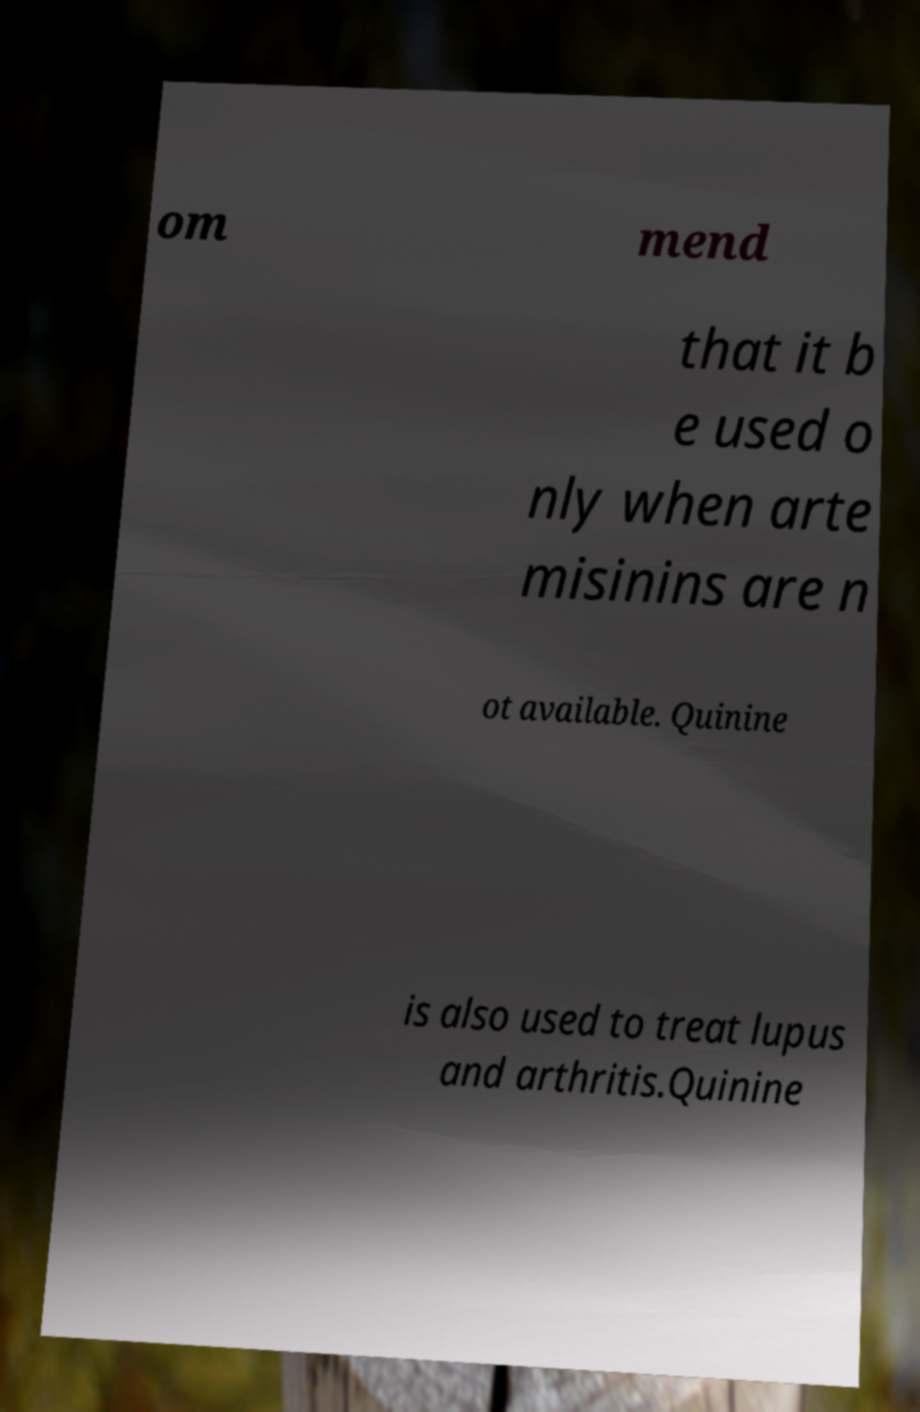Please read and relay the text visible in this image. What does it say? om mend that it b e used o nly when arte misinins are n ot available. Quinine is also used to treat lupus and arthritis.Quinine 